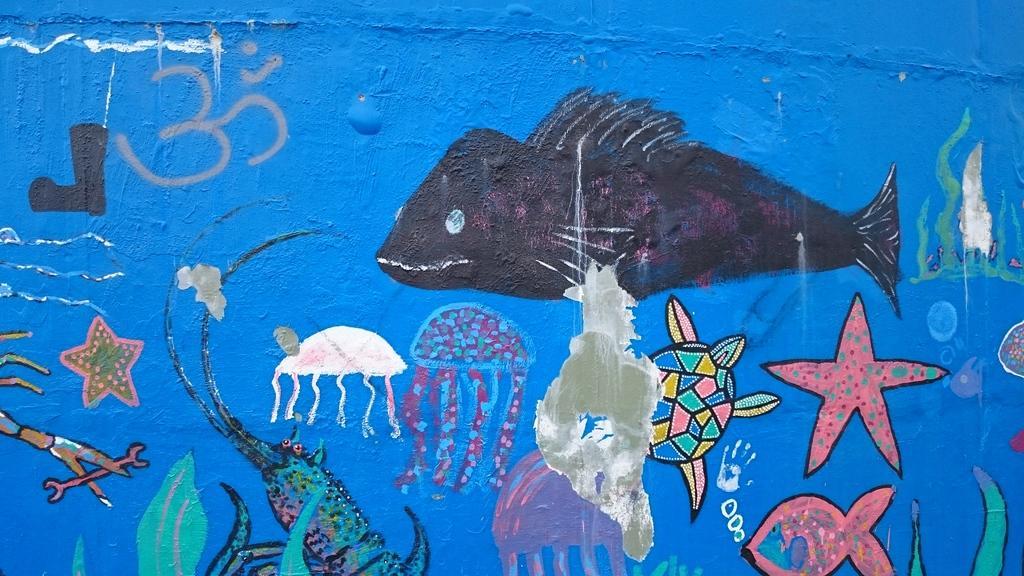Please provide a concise description of this image. In this image I can see few paintings on the wall. 